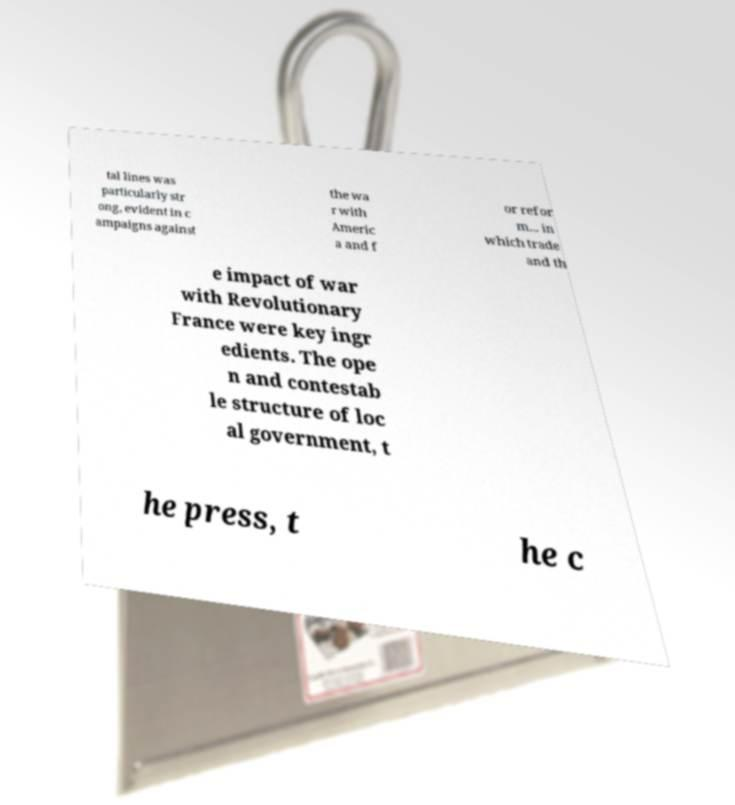Could you extract and type out the text from this image? tal lines was particularly str ong, evident in c ampaigns against the wa r with Americ a and f or refor m... in which trade and th e impact of war with Revolutionary France were key ingr edients. The ope n and contestab le structure of loc al government, t he press, t he c 